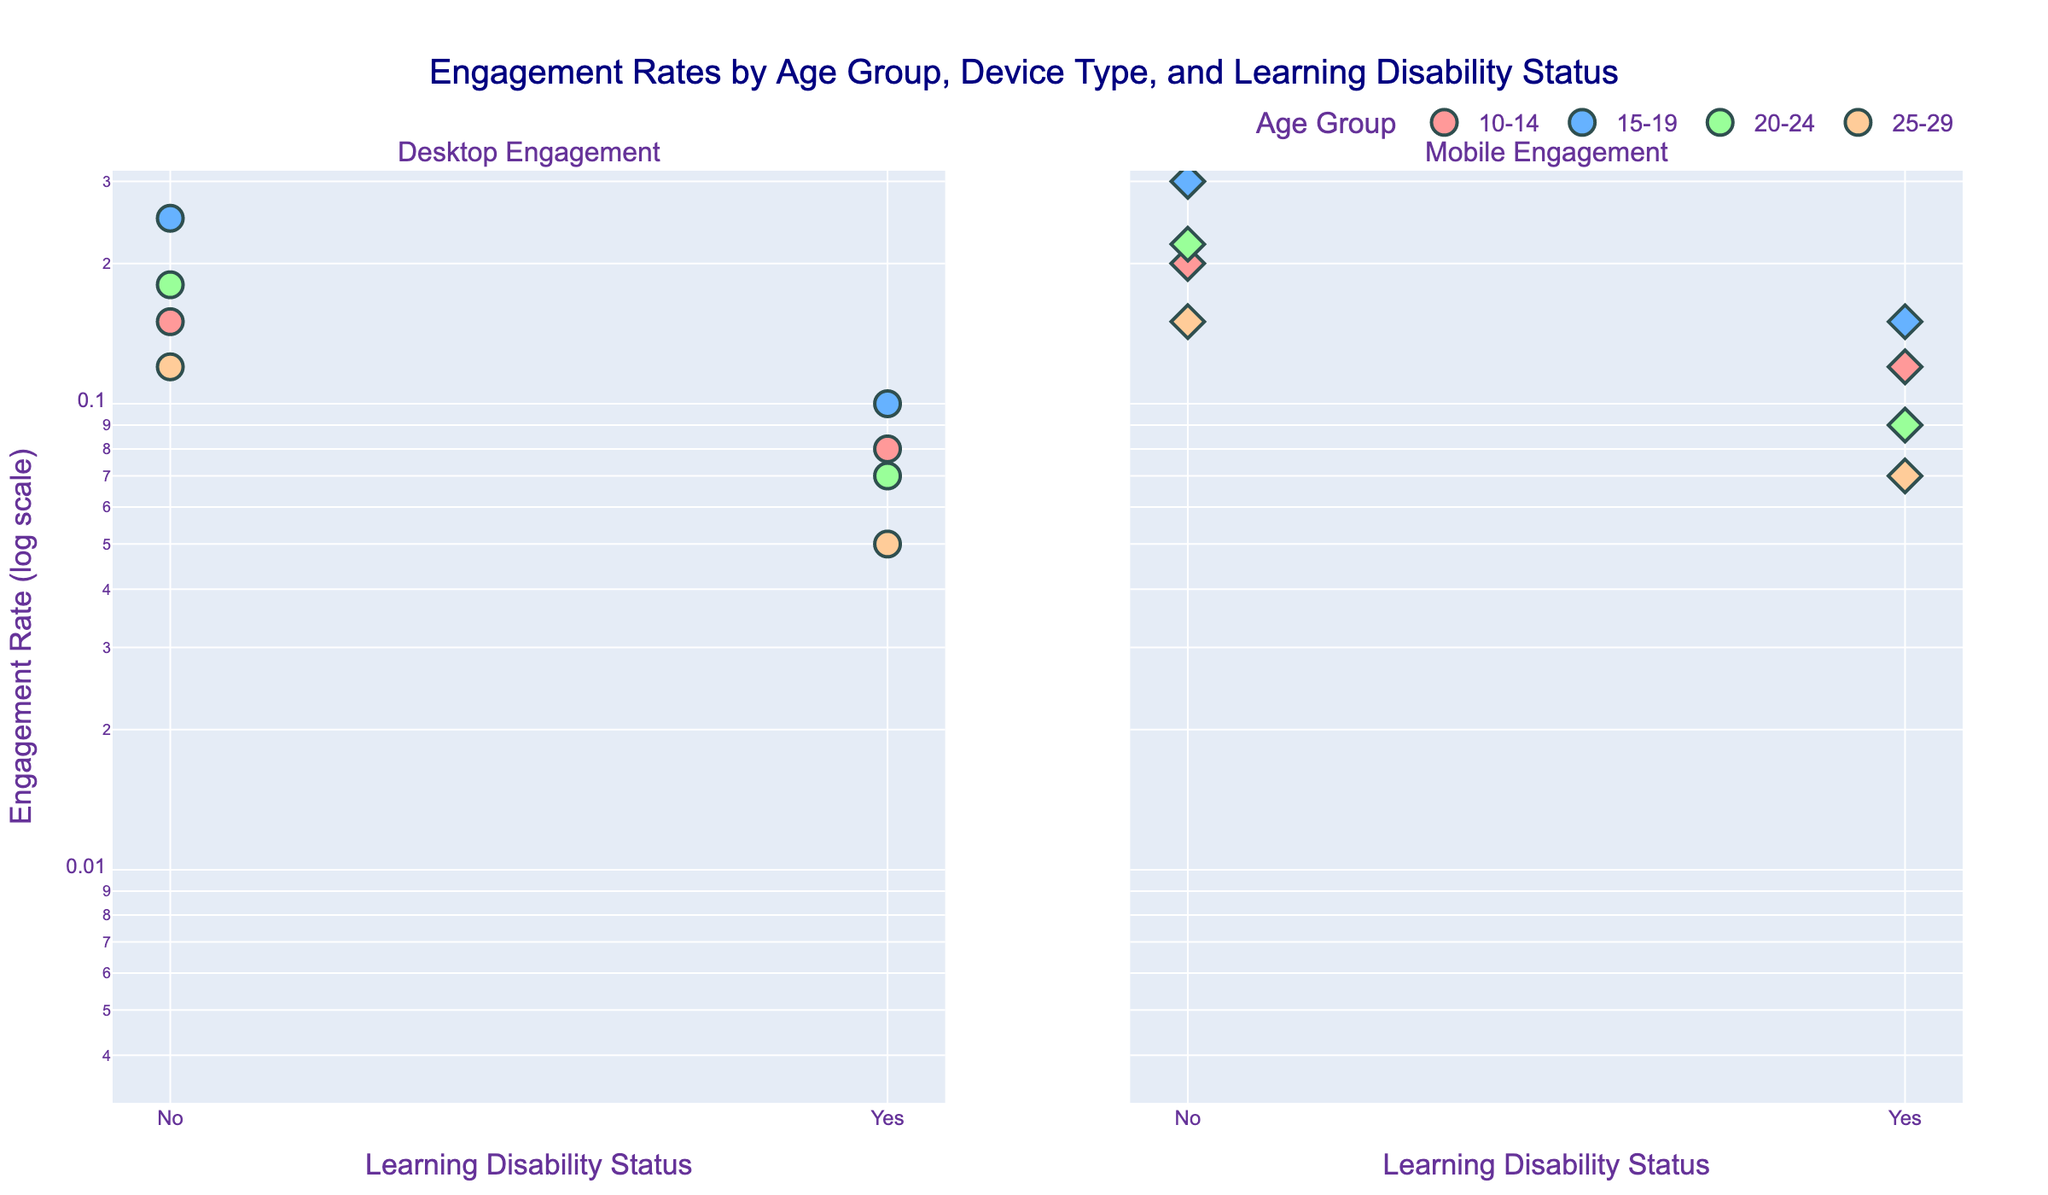Which age group has the highest engagement rate on mobile devices without a learning disability? By looking at the mobile engagement subplot and identifying the highest y-coordinate for points where the x-coordinate indicates "No" learning disability, we can see which age group it belongs to. The highest engagement rate without a learning disability on mobile devices is 0.30 for the 15-19 age group.
Answer: 15-19 What is the engagement rate for students aged 20-24 using desktop devices with a learning disability? Locate the data points in the desktop subplot where the x-coordinate indicates learning disabilities and the trace corresponds to the 20-24 age group. The engagement rate for 20-24 age group with a learning disability is 0.07.
Answer: 0.07 Are engagement rates on desktop or mobile devices generally higher for students without learning disabilities? Compare the y-coordinates of data points without a learning disability in both the desktop and mobile subplots. Generally, the mobile subplot shows higher engagement rates compared to the desktop subplot for students without learning disabilities.
Answer: Mobile Which device shows a larger disparity in engagement rates between students with and without learning disabilities in the 10-14 age group? Examine the gap between the points for "Yes" and "No" learning disabilities in both device subplots for the 10-14 age group. On desktops, the engagement rates are 0.08 (Yes) vs 0.15 (No), and on mobiles, they are 0.12 (Yes) vs 0.20 (No). The disparity is larger on desktop devices.
Answer: Desktop How many age groups have a lower engagement rate on mobile devices for students with learning disabilities than those without? For each age group, compare the y-coordinates of data points for "Yes" and "No" learning disabilities in the mobile subplot. All four age groups (10-14, 15-19, 20-24, 25-29) show lower engagement rates for students with learning disabilities.
Answer: 4 What is the engagement rate for students aged 25-29 with learning disabilities using desktop devices? Identify the data point in the desktop subplot related to the 25-29 age group with "Yes" learning disabilities. The engagement rate is 0.05.
Answer: 0.05 Which age group has the smallest difference in engagement rates between students with and without learning disabilities for mobile devices? Calculate the difference between the points for "Yes" and "No" learning disabilities in the mobile subplot for each age group. The differences are: 0.08 for 10-14, 0.15 for 15-19, 0.13 for 20-24, and 0.08 for 25-29. The smallest difference is between students aged 10-14 and 25-29, both at 0.08.
Answer: 10-14 and 25-29 What is the relationship between age group and engagement rate for mobile devices for students without learning disabilities? Identify the trend of engagement rates for students without learning disabilities within the mobile subplot and note the age group. The order of engagement rate from lowest to highest is 10-14 (0.20), 25-29 (0.15), 20-24 (0.22), and 15-19 (0.30), indicating that the rate doesn't strictly increase or decrease with age.
Answer: It's variable Which device type shows a more significant engagement rate for the 15-19 age group without learning disabilities? Compare the y-coordinates for points marked by "No" learning disability in both subplots for the 15-19 age group. Mobile devices show a higher engagement rate (0.30) compared to desktop devices (0.25).
Answer: Mobile 